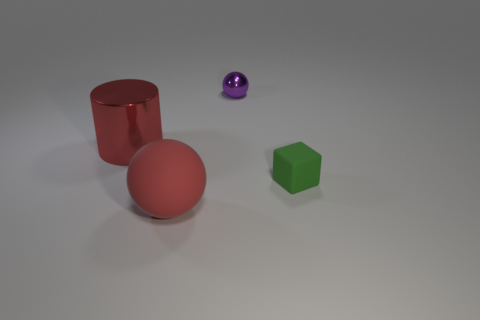There is a sphere on the right side of the red rubber ball; what is its color? purple 